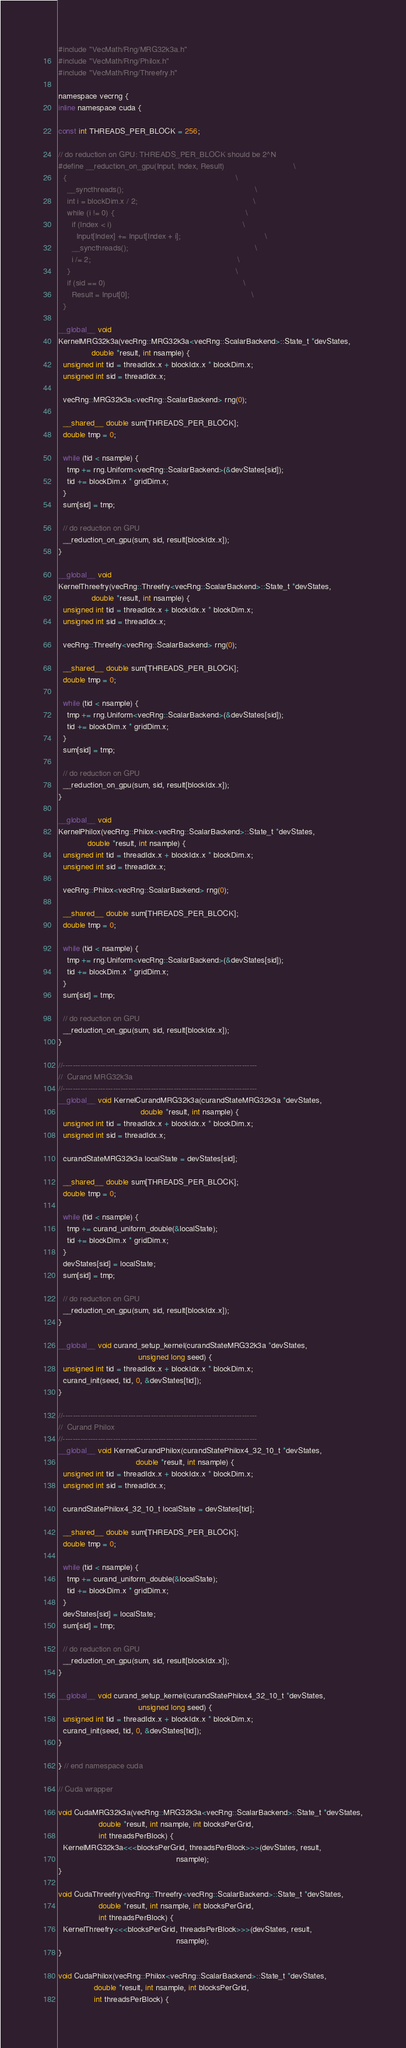Convert code to text. <code><loc_0><loc_0><loc_500><loc_500><_Cuda_>#include "VecMath/Rng/MRG32k3a.h"
#include "VecMath/Rng/Philox.h"
#include "VecMath/Rng/Threefry.h"

namespace vecrng {
inline namespace cuda {

const int THREADS_PER_BLOCK = 256;

// do reduction on GPU: THREADS_PER_BLOCK should be 2^N
#define __reduction_on_gpu(Input, Index, Result)                               \
  {                                                                            \
    __syncthreads();                                                           \
    int i = blockDim.x / 2;                                                    \
    while (i != 0) {                                                           \
      if (Index < i)                                                           \
        Input[Index] += Input[Index + i];                                      \
      __syncthreads();                                                         \
      i /= 2;                                                                  \
    }                                                                          \
    if (sid == 0)                                                              \
      Result = Input[0];                                                       \
  }

__global__ void
KernelMRG32k3a(vecRng::MRG32k3a<vecRng::ScalarBackend>::State_t *devStates,
               double *result, int nsample) {
  unsigned int tid = threadIdx.x + blockIdx.x * blockDim.x;
  unsigned int sid = threadIdx.x;

  vecRng::MRG32k3a<vecRng::ScalarBackend> rng(0);

  __shared__ double sum[THREADS_PER_BLOCK];
  double tmp = 0;

  while (tid < nsample) {
    tmp += rng.Uniform<vecRng::ScalarBackend>(&devStates[sid]);
    tid += blockDim.x * gridDim.x;
  }
  sum[sid] = tmp;

  // do reduction on GPU
  __reduction_on_gpu(sum, sid, result[blockIdx.x]);
}

__global__ void
KernelThreefry(vecRng::Threefry<vecRng::ScalarBackend>::State_t *devStates,
               double *result, int nsample) {
  unsigned int tid = threadIdx.x + blockIdx.x * blockDim.x;
  unsigned int sid = threadIdx.x;

  vecRng::Threefry<vecRng::ScalarBackend> rng(0);

  __shared__ double sum[THREADS_PER_BLOCK];
  double tmp = 0;

  while (tid < nsample) {
    tmp += rng.Uniform<vecRng::ScalarBackend>(&devStates[sid]);
    tid += blockDim.x * gridDim.x;
  }
  sum[sid] = tmp;

  // do reduction on GPU
  __reduction_on_gpu(sum, sid, result[blockIdx.x]);
}

__global__ void
KernelPhilox(vecRng::Philox<vecRng::ScalarBackend>::State_t *devStates,
             double *result, int nsample) {
  unsigned int tid = threadIdx.x + blockIdx.x * blockDim.x;
  unsigned int sid = threadIdx.x;

  vecRng::Philox<vecRng::ScalarBackend> rng(0);

  __shared__ double sum[THREADS_PER_BLOCK];
  double tmp = 0;

  while (tid < nsample) {
    tmp += rng.Uniform<vecRng::ScalarBackend>(&devStates[sid]);
    tid += blockDim.x * gridDim.x;
  }
  sum[sid] = tmp;

  // do reduction on GPU
  __reduction_on_gpu(sum, sid, result[blockIdx.x]);
}

//-----------------------------------------------------------------------------
//  Curand MRG32k3a
//-----------------------------------------------------------------------------
__global__ void KernelCurandMRG32k3a(curandStateMRG32k3a *devStates,
                                     double *result, int nsample) {
  unsigned int tid = threadIdx.x + blockIdx.x * blockDim.x;
  unsigned int sid = threadIdx.x;

  curandStateMRG32k3a localState = devStates[sid];

  __shared__ double sum[THREADS_PER_BLOCK];
  double tmp = 0;

  while (tid < nsample) {
    tmp += curand_uniform_double(&localState);
    tid += blockDim.x * gridDim.x;
  }
  devStates[sid] = localState;
  sum[sid] = tmp;

  // do reduction on GPU
  __reduction_on_gpu(sum, sid, result[blockIdx.x]);
}

__global__ void curand_setup_kernel(curandStateMRG32k3a *devStates,
                                    unsigned long seed) {
  unsigned int tid = threadIdx.x + blockIdx.x * blockDim.x;
  curand_init(seed, tid, 0, &devStates[tid]);
}

//-----------------------------------------------------------------------------
//  Curand Philox
//-----------------------------------------------------------------------------
__global__ void KernelCurandPhilox(curandStatePhilox4_32_10_t *devStates,
                                   double *result, int nsample) {
  unsigned int tid = threadIdx.x + blockIdx.x * blockDim.x;
  unsigned int sid = threadIdx.x;

  curandStatePhilox4_32_10_t localState = devStates[tid];

  __shared__ double sum[THREADS_PER_BLOCK];
  double tmp = 0;

  while (tid < nsample) {
    tmp += curand_uniform_double(&localState);
    tid += blockDim.x * gridDim.x;
  }
  devStates[sid] = localState;
  sum[sid] = tmp;

  // do reduction on GPU
  __reduction_on_gpu(sum, sid, result[blockIdx.x]);
}

__global__ void curand_setup_kernel(curandStatePhilox4_32_10_t *devStates,
                                    unsigned long seed) {
  unsigned int tid = threadIdx.x + blockIdx.x * blockDim.x;
  curand_init(seed, tid, 0, &devStates[tid]);
}

} // end namespace cuda

// Cuda wrapper

void CudaMRG32k3a(vecRng::MRG32k3a<vecRng::ScalarBackend>::State_t *devStates,
                  double *result, int nsample, int blocksPerGrid,
                  int threadsPerBlock) {
  KernelMRG32k3a<<<blocksPerGrid, threadsPerBlock>>>(devStates, result,
                                                     nsample);
}

void CudaThreefry(vecRng::Threefry<vecRng::ScalarBackend>::State_t *devStates,
                  double *result, int nsample, int blocksPerGrid,
                  int threadsPerBlock) {
  KernelThreefry<<<blocksPerGrid, threadsPerBlock>>>(devStates, result,
                                                     nsample);
}

void CudaPhilox(vecRng::Philox<vecRng::ScalarBackend>::State_t *devStates,
                double *result, int nsample, int blocksPerGrid,
                int threadsPerBlock) {</code> 